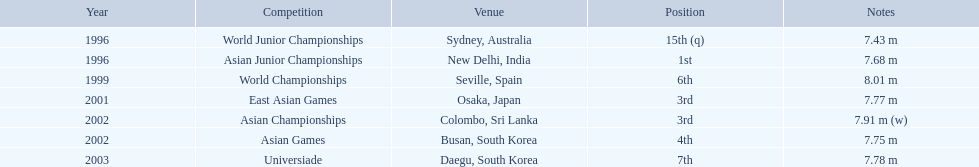What leaps did huang le perform in 2002? 7.91 m (w), 7.75 m. Which leap had the greatest distance? 7.91 m (w). 